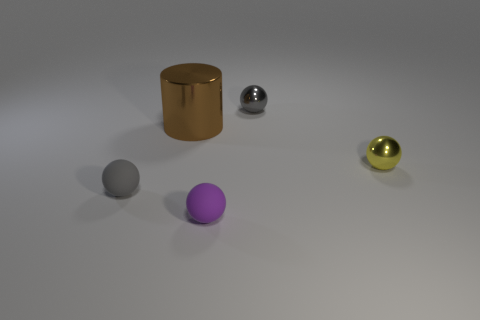Is there any other thing that has the same shape as the large brown thing?
Provide a short and direct response. No. Is the shape of the purple thing the same as the small gray shiny object?
Provide a short and direct response. Yes. Is there any other thing that is the same material as the purple object?
Give a very brief answer. Yes. How big is the yellow object?
Give a very brief answer. Small. There is a object that is in front of the large brown thing and to the left of the purple thing; what is its color?
Give a very brief answer. Gray. Is the number of big cyan metallic spheres greater than the number of brown cylinders?
Give a very brief answer. No. What number of objects are tiny metallic things or large brown metal things to the left of the gray metallic ball?
Keep it short and to the point. 3. Do the brown cylinder and the gray matte object have the same size?
Keep it short and to the point. No. There is a small purple object; are there any small purple matte spheres right of it?
Give a very brief answer. No. There is a sphere that is both behind the tiny gray rubber ball and in front of the large cylinder; what is its size?
Offer a very short reply. Small. 